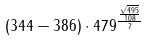Convert formula to latex. <formula><loc_0><loc_0><loc_500><loc_500>( 3 4 4 - 3 8 6 ) \cdot 4 7 9 ^ { \frac { \frac { \sqrt { 4 9 5 } } { 1 0 8 } } { 7 } }</formula> 